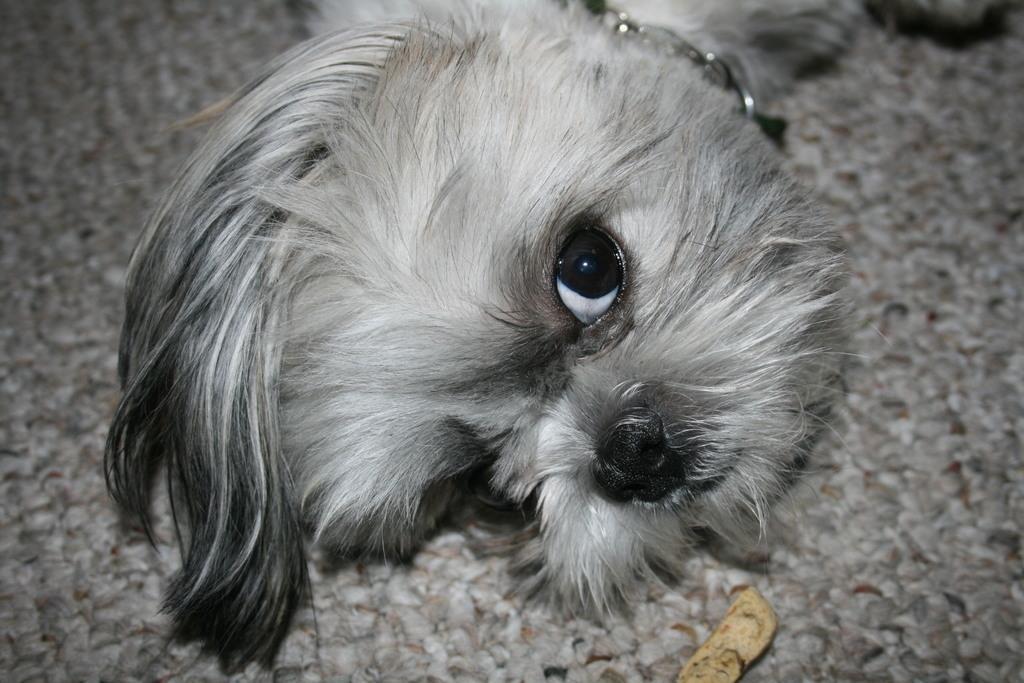What type of animal is present in the image? There is a dog in the image. What is the dog lying on? The dog is lying on a cloth. What else can be seen on the cloth? There is an object on the cloth. How is the dog secured or controlled? The dog has a chain. What type of silk is being distributed in the image? There is no silk or distribution of any kind present in the image. 